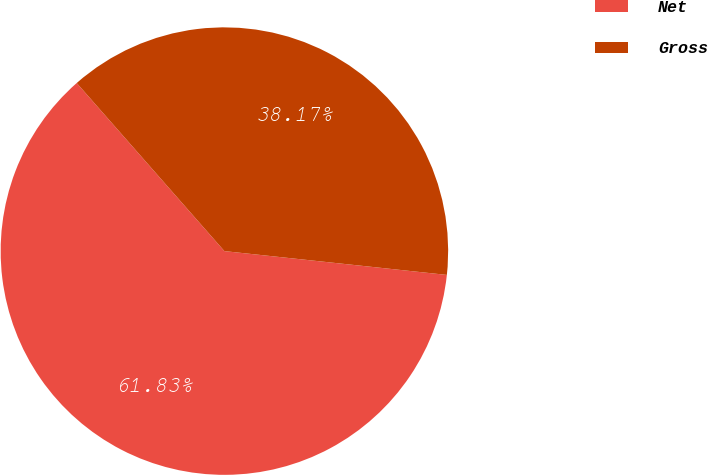Convert chart to OTSL. <chart><loc_0><loc_0><loc_500><loc_500><pie_chart><fcel>Net<fcel>Gross<nl><fcel>61.83%<fcel>38.17%<nl></chart> 